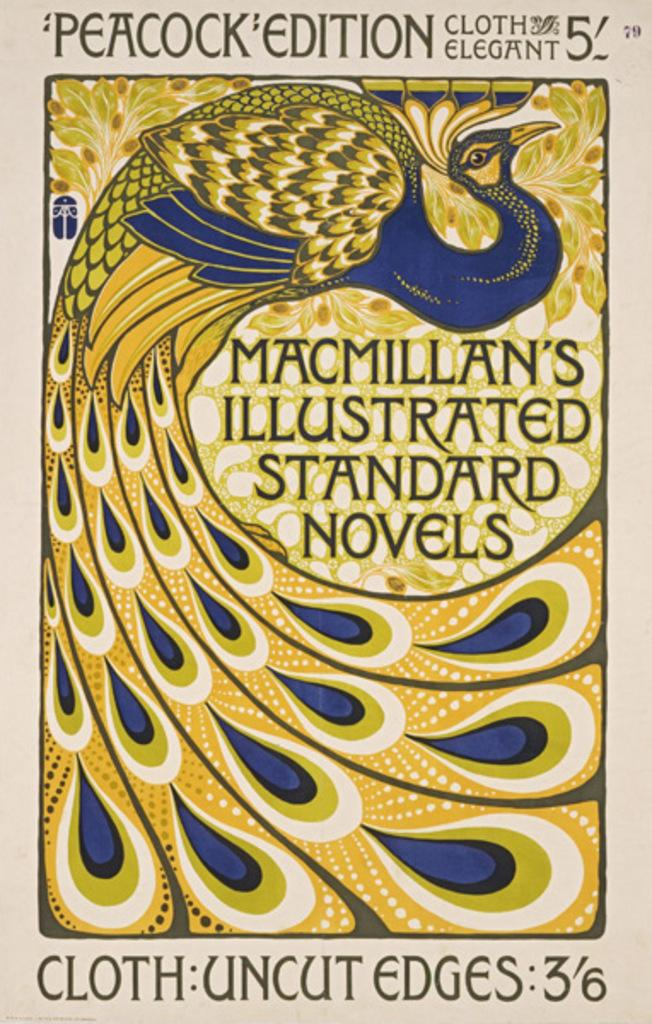<image>
Give a short and clear explanation of the subsequent image. yellow and blue macmillan's illustrated standard novels peacock edition 